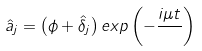<formula> <loc_0><loc_0><loc_500><loc_500>\hat { a } _ { j } = \left ( \phi + \hat { \delta } _ { j } \right ) e x p \left ( - \frac { i \mu t } { } \right )</formula> 